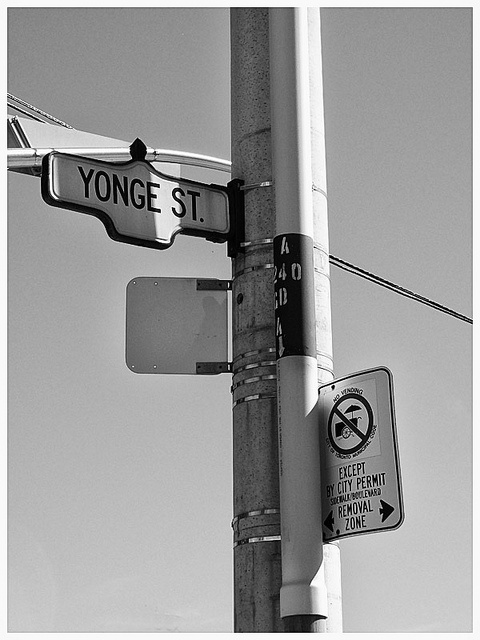Describe the objects in this image and their specific colors. I can see various objects in this image with different colors. 